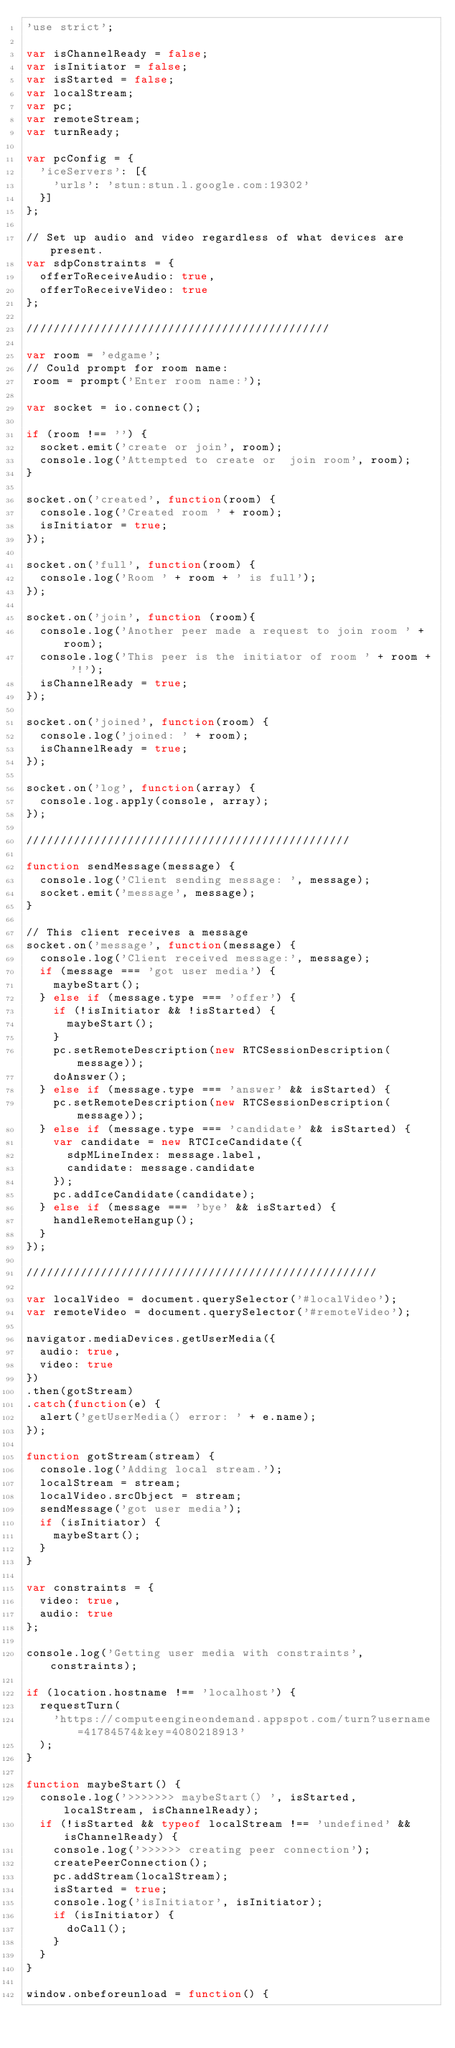Convert code to text. <code><loc_0><loc_0><loc_500><loc_500><_JavaScript_>'use strict';

var isChannelReady = false;
var isInitiator = false;
var isStarted = false;
var localStream;
var pc;
var remoteStream;
var turnReady;

var pcConfig = {
  'iceServers': [{
    'urls': 'stun:stun.l.google.com:19302'
  }]
};

// Set up audio and video regardless of what devices are present.
var sdpConstraints = {
  offerToReceiveAudio: true,
  offerToReceiveVideo: true
};

/////////////////////////////////////////////

var room = 'edgame';
// Could prompt for room name:
 room = prompt('Enter room name:');

var socket = io.connect();

if (room !== '') {
  socket.emit('create or join', room);
  console.log('Attempted to create or  join room', room);
}

socket.on('created', function(room) {
  console.log('Created room ' + room);
  isInitiator = true;
});

socket.on('full', function(room) {
  console.log('Room ' + room + ' is full');
});

socket.on('join', function (room){
  console.log('Another peer made a request to join room ' + room);
  console.log('This peer is the initiator of room ' + room + '!');
  isChannelReady = true;
});

socket.on('joined', function(room) {
  console.log('joined: ' + room);
  isChannelReady = true;
});

socket.on('log', function(array) {
  console.log.apply(console, array);
});

////////////////////////////////////////////////

function sendMessage(message) {
  console.log('Client sending message: ', message);
  socket.emit('message', message);
}

// This client receives a message
socket.on('message', function(message) {
  console.log('Client received message:', message);
  if (message === 'got user media') {
    maybeStart();
  } else if (message.type === 'offer') {
    if (!isInitiator && !isStarted) {
      maybeStart();
    }
    pc.setRemoteDescription(new RTCSessionDescription(message));
    doAnswer();
  } else if (message.type === 'answer' && isStarted) {
    pc.setRemoteDescription(new RTCSessionDescription(message));
  } else if (message.type === 'candidate' && isStarted) {
    var candidate = new RTCIceCandidate({
      sdpMLineIndex: message.label,
      candidate: message.candidate
    });
    pc.addIceCandidate(candidate);
  } else if (message === 'bye' && isStarted) {
    handleRemoteHangup();
  }
});

////////////////////////////////////////////////////

var localVideo = document.querySelector('#localVideo');
var remoteVideo = document.querySelector('#remoteVideo');

navigator.mediaDevices.getUserMedia({
  audio: true,
  video: true
})
.then(gotStream)
.catch(function(e) {
  alert('getUserMedia() error: ' + e.name);
});

function gotStream(stream) {
  console.log('Adding local stream.');
  localStream = stream;
  localVideo.srcObject = stream;
  sendMessage('got user media');
  if (isInitiator) {
    maybeStart();
  }
}

var constraints = {
  video: true,
  audio: true
};

console.log('Getting user media with constraints', constraints);

if (location.hostname !== 'localhost') {
  requestTurn(
    'https://computeengineondemand.appspot.com/turn?username=41784574&key=4080218913'
  );
}

function maybeStart() {
  console.log('>>>>>>> maybeStart() ', isStarted, localStream, isChannelReady);
  if (!isStarted && typeof localStream !== 'undefined' && isChannelReady) {
    console.log('>>>>>> creating peer connection');
    createPeerConnection();
    pc.addStream(localStream);
    isStarted = true;
    console.log('isInitiator', isInitiator);
    if (isInitiator) {
      doCall();
    }
  }
}

window.onbeforeunload = function() {</code> 